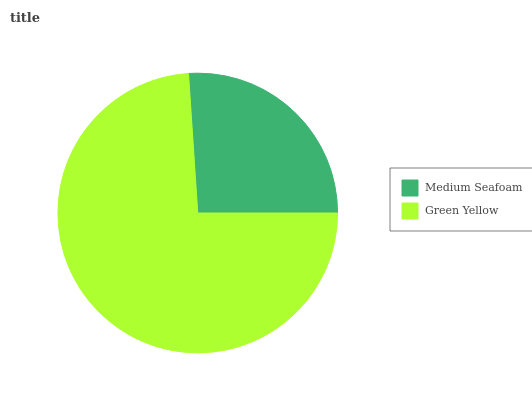Is Medium Seafoam the minimum?
Answer yes or no. Yes. Is Green Yellow the maximum?
Answer yes or no. Yes. Is Green Yellow the minimum?
Answer yes or no. No. Is Green Yellow greater than Medium Seafoam?
Answer yes or no. Yes. Is Medium Seafoam less than Green Yellow?
Answer yes or no. Yes. Is Medium Seafoam greater than Green Yellow?
Answer yes or no. No. Is Green Yellow less than Medium Seafoam?
Answer yes or no. No. Is Green Yellow the high median?
Answer yes or no. Yes. Is Medium Seafoam the low median?
Answer yes or no. Yes. Is Medium Seafoam the high median?
Answer yes or no. No. Is Green Yellow the low median?
Answer yes or no. No. 